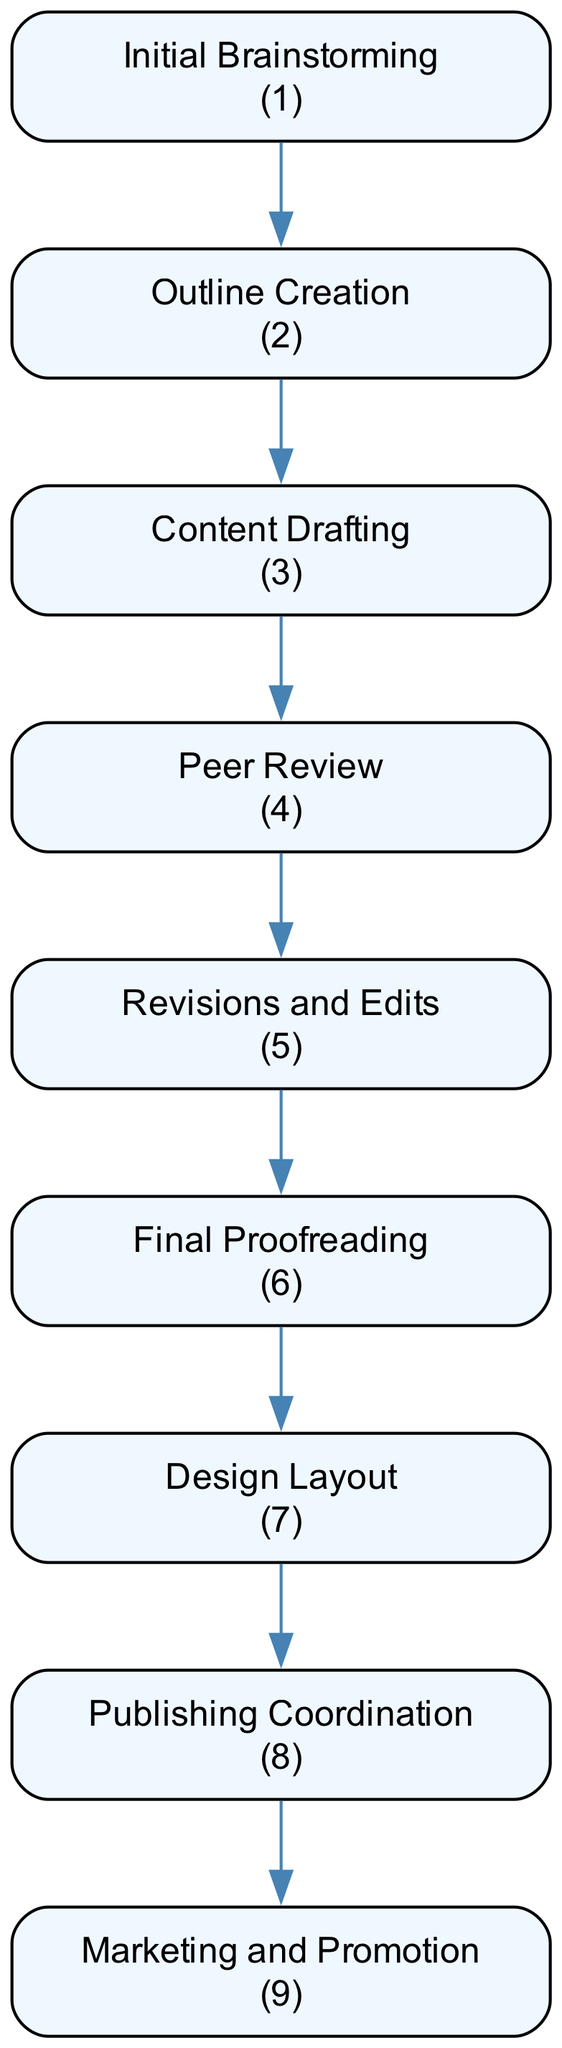What is the first step in the publication process? The diagram shows "Initial Brainstorming" as the first node, indicating that discussions on key concepts and strategies take place here.
Answer: Initial Brainstorming How many steps are there in the publication process? By counting all the nodes in the diagram, we can see there are nine distinct steps listed for the publication process of the chess strategy guide.
Answer: Nine Which step directly follows "Content Drafting"? The diagram indicates that "Peer Review" is the next step that follows "Content Drafting," as it is directly connected to it in the flow of the publication process.
Answer: Peer Review What is the last step in the publication process? The last node in the diagram is "Marketing and Promotion," indicating this as the final step in the flow of the publication process for the chess strategy guide.
Answer: Marketing and Promotion Which two steps are adjacent to "Revisions and Edits"? The diagram shows that "Peer Review" precedes "Revisions and Edits" while "Final Proofreading" follows it, making these the adjacent steps in the process.
Answer: Peer Review and Final Proofreading How does "Design Layout" relate to the other steps? The diagram indicates that "Design Layout" comes after "Revisions and Edits" and before "Publishing Coordination," showing its position in the sequence of the publication process.
Answer: It follows Revisions and Edits and precedes Publishing Coordination What is the purpose of the "Peer Review" step? The "Peer Review" step is designed for fellow chess experts to review the drafts for accuracy and comprehensiveness, which is essential for maintaining quality in the guide.
Answer: Review drafts for accuracy and comprehensiveness How many edits are done through the process before publishing? The process shows two distinct stages that imply edits: "Revisions and Edits" and "Final Proofreading." Thus, there are effectively two editing stages before publishing.
Answer: Two What is the main focus during "Outline Creation"? The purpose during "Outline Creation" is to develop a structured outline for the chapters and sections, effectively organizing the content in advance of drafting.
Answer: Develop a structured outline 